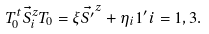<formula> <loc_0><loc_0><loc_500><loc_500>T _ { 0 } ^ { t } \vec { S } _ { i } ^ { z } T _ { 0 } = \xi \vec { S ^ { \prime } } ^ { z } + \eta _ { i } 1 ^ { \prime } i = 1 , 3 .</formula> 